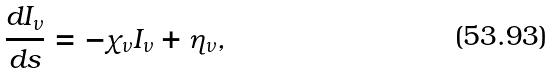<formula> <loc_0><loc_0><loc_500><loc_500>\frac { d I _ { \nu } } { d s } = - \chi _ { \nu } I _ { \nu } + \eta _ { \nu } ,</formula> 